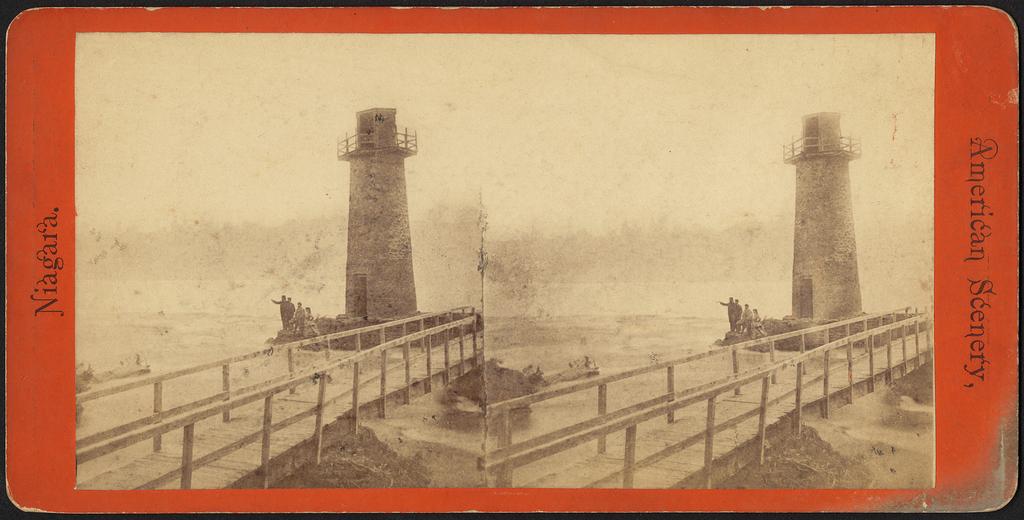What is the listed location on the left side of the photo?
Provide a short and direct response. Niagara. What is the title of the postcard indicated on the right?
Provide a succinct answer. American scenery. 